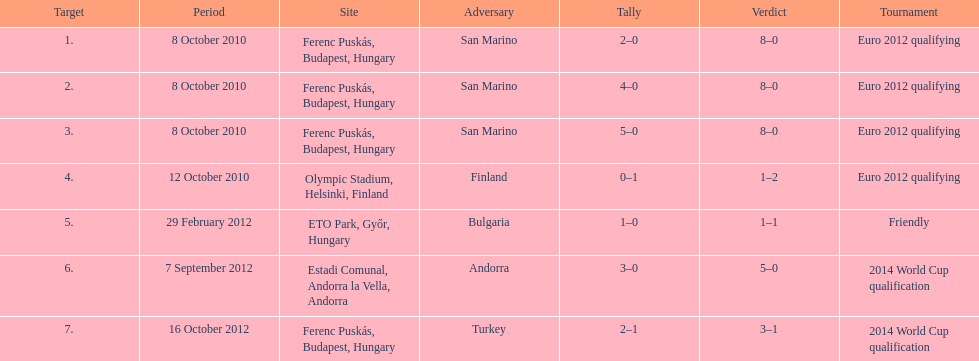What is the total number of international goals ádám szalai has made? 7. 